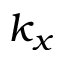<formula> <loc_0><loc_0><loc_500><loc_500>k _ { x }</formula> 